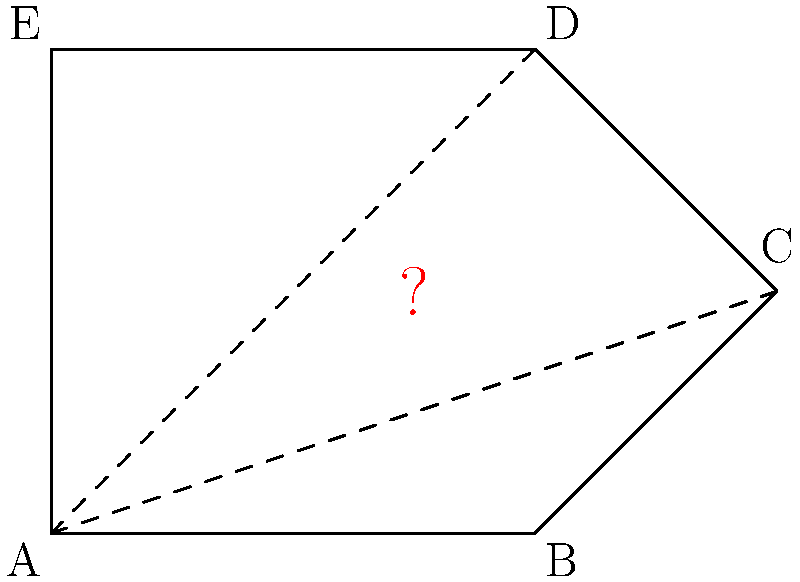In this regular pentagon ABCDE, what is the measure of each interior angle? Express your answer in degrees, rounded to the nearest whole number. Justify your answer using the properties of regular polygons and elementary geometry. To find the measure of each interior angle in a regular pentagon:

1. Recall the formula for the sum of interior angles of any polygon:
   $$(n-2) \times 180^\circ$$
   where $n$ is the number of sides.

2. For a pentagon, $n = 5$:
   $$(5-2) \times 180^\circ = 3 \times 180^\circ = 540^\circ$$

3. In a regular polygon, all interior angles are equal. To find each angle:
   $$\frac{540^\circ}{5} = 108^\circ$$

4. Verification using central angle:
   - Central angle of a regular polygon = $\frac{360^\circ}{n} = \frac{360^\circ}{5} = 72^\circ$
   - Interior angle + half of central angle = $180^\circ$
   - Interior angle = $180^\circ - \frac{72^\circ}{2} = 180^\circ - 36^\circ = 144^\circ$

5. The result is exactly $108^\circ$, so no rounding is necessary.

This approach demonstrates a thorough understanding of polygon properties and provides multiple methods for verification, meeting the high expectations set for primary school geometry education.
Answer: $108^\circ$ 